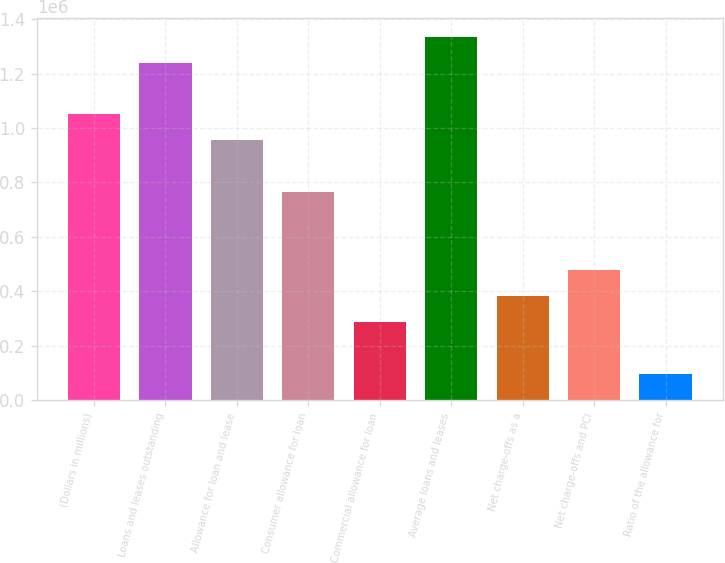Convert chart. <chart><loc_0><loc_0><loc_500><loc_500><bar_chart><fcel>(Dollars in millions)<fcel>Loans and leases outstanding<fcel>Allowance for loan and lease<fcel>Consumer allowance for loan<fcel>Commercial allowance for loan<fcel>Average loans and leases<fcel>Net charge-offs as a<fcel>Net charge-offs and PCI<fcel>Ratio of the allowance for<nl><fcel>1.04971e+06<fcel>1.24056e+06<fcel>954278<fcel>763423<fcel>286284<fcel>1.33599e+06<fcel>381712<fcel>477140<fcel>95428.7<nl></chart> 